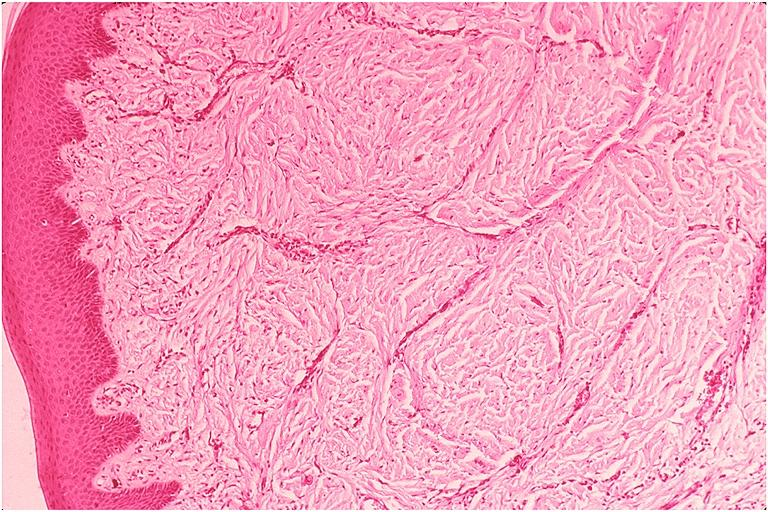s periprostatic vein thrombi present?
Answer the question using a single word or phrase. No 